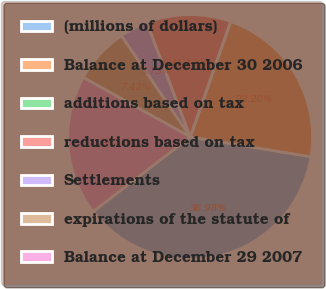Convert chart. <chart><loc_0><loc_0><loc_500><loc_500><pie_chart><fcel>(millions of dollars)<fcel>Balance at December 30 2006<fcel>additions based on tax<fcel>reductions based on tax<fcel>Settlements<fcel>expirations of the statute of<fcel>Balance at December 29 2007<nl><fcel>36.98%<fcel>22.2%<fcel>0.03%<fcel>11.12%<fcel>3.73%<fcel>7.42%<fcel>18.51%<nl></chart> 